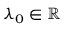Convert formula to latex. <formula><loc_0><loc_0><loc_500><loc_500>\lambda _ { 0 } \in \mathbb { R }</formula> 